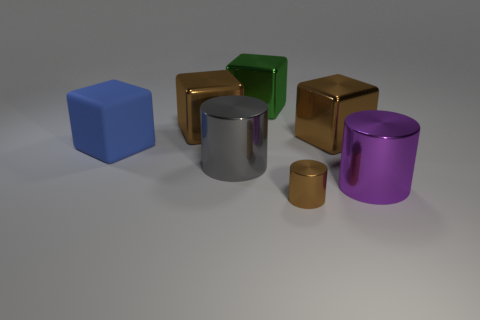Is the shape of the brown thing that is in front of the purple object the same as  the large green shiny thing?
Offer a terse response. No. There is a brown thing that is in front of the large blue cube; what is it made of?
Your answer should be very brief. Metal. The brown object that is both to the right of the large gray shiny object and behind the big purple thing has what shape?
Your response must be concise. Cube. What is the material of the small cylinder?
Keep it short and to the point. Metal. How many blocks are either big gray metallic objects or large objects?
Keep it short and to the point. 4. Is the material of the large green cube the same as the tiny brown thing?
Offer a very short reply. Yes. What is the size of the green metal object that is the same shape as the blue object?
Keep it short and to the point. Large. There is a object that is to the right of the gray metallic cylinder and to the left of the tiny brown thing; what material is it?
Offer a terse response. Metal. Is the number of large blue matte blocks that are in front of the gray object the same as the number of big blue rubber things?
Your response must be concise. No. What number of things are large metallic cylinders that are to the left of the tiny cylinder or blocks?
Ensure brevity in your answer.  5. 